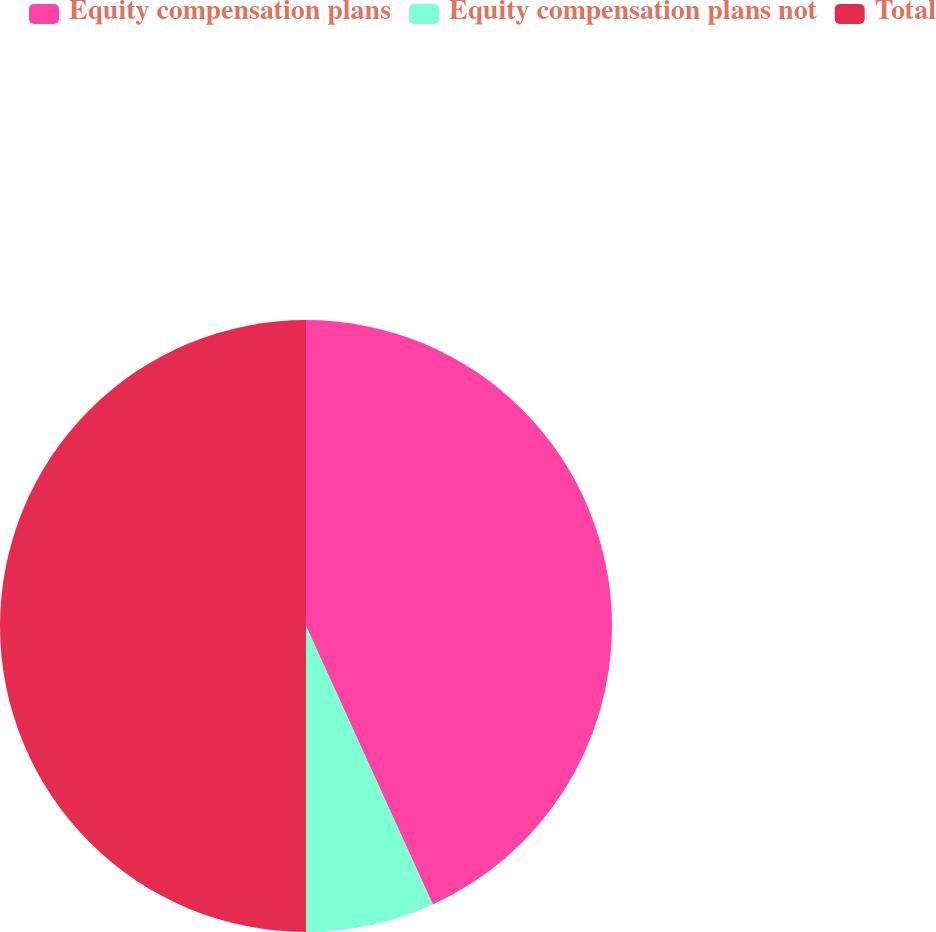<chart> <loc_0><loc_0><loc_500><loc_500><pie_chart><fcel>Equity compensation plans<fcel>Equity compensation plans not<fcel>Total<nl><fcel>43.2%<fcel>6.8%<fcel>50.0%<nl></chart> 